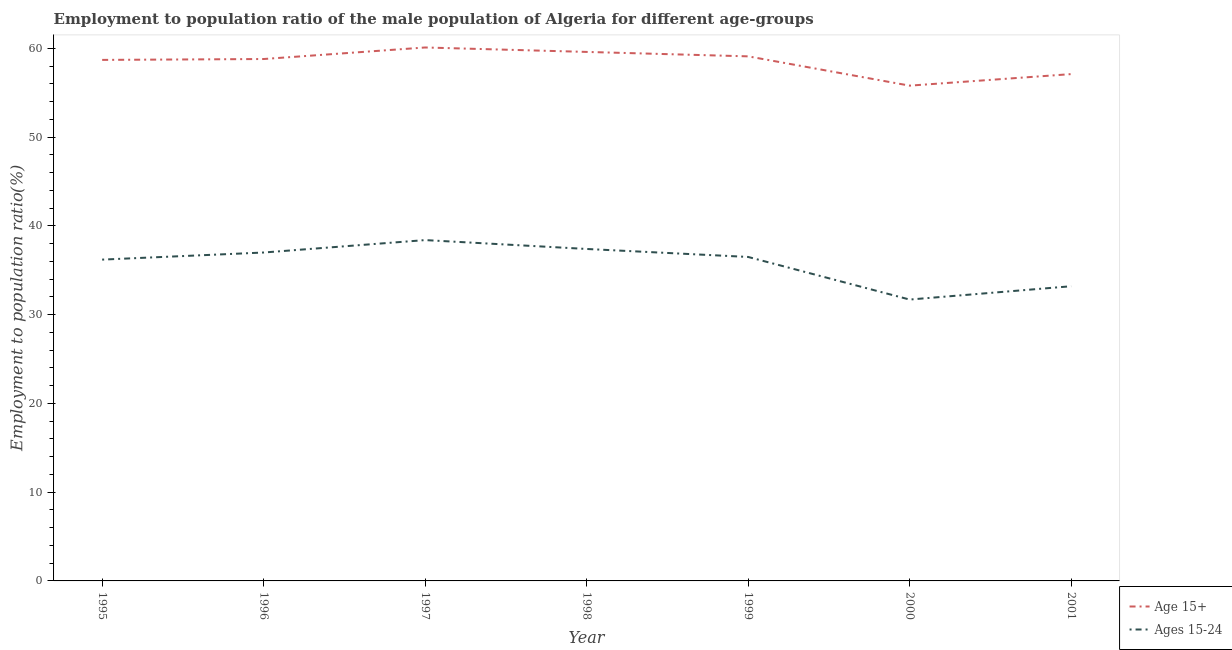How many different coloured lines are there?
Provide a succinct answer. 2. Does the line corresponding to employment to population ratio(age 15-24) intersect with the line corresponding to employment to population ratio(age 15+)?
Ensure brevity in your answer.  No. Is the number of lines equal to the number of legend labels?
Your answer should be compact. Yes. What is the employment to population ratio(age 15-24) in 1999?
Provide a short and direct response. 36.5. Across all years, what is the maximum employment to population ratio(age 15-24)?
Offer a very short reply. 38.4. Across all years, what is the minimum employment to population ratio(age 15-24)?
Offer a terse response. 31.7. In which year was the employment to population ratio(age 15+) maximum?
Ensure brevity in your answer.  1997. What is the total employment to population ratio(age 15+) in the graph?
Offer a terse response. 409.2. What is the difference between the employment to population ratio(age 15+) in 1998 and that in 2000?
Ensure brevity in your answer.  3.8. What is the difference between the employment to population ratio(age 15+) in 1996 and the employment to population ratio(age 15-24) in 1999?
Make the answer very short. 22.3. What is the average employment to population ratio(age 15+) per year?
Your answer should be compact. 58.46. In the year 1999, what is the difference between the employment to population ratio(age 15-24) and employment to population ratio(age 15+)?
Provide a succinct answer. -22.6. In how many years, is the employment to population ratio(age 15-24) greater than 44 %?
Provide a short and direct response. 0. What is the ratio of the employment to population ratio(age 15+) in 1998 to that in 2001?
Offer a very short reply. 1.04. Is the employment to population ratio(age 15+) in 1995 less than that in 1998?
Your answer should be very brief. Yes. What is the difference between the highest and the second highest employment to population ratio(age 15-24)?
Your answer should be compact. 1. What is the difference between the highest and the lowest employment to population ratio(age 15-24)?
Keep it short and to the point. 6.7. Is the sum of the employment to population ratio(age 15+) in 2000 and 2001 greater than the maximum employment to population ratio(age 15-24) across all years?
Keep it short and to the point. Yes. How many years are there in the graph?
Keep it short and to the point. 7. What is the difference between two consecutive major ticks on the Y-axis?
Make the answer very short. 10. How many legend labels are there?
Offer a very short reply. 2. What is the title of the graph?
Provide a short and direct response. Employment to population ratio of the male population of Algeria for different age-groups. Does "Travel services" appear as one of the legend labels in the graph?
Offer a very short reply. No. What is the Employment to population ratio(%) in Age 15+ in 1995?
Your answer should be compact. 58.7. What is the Employment to population ratio(%) of Ages 15-24 in 1995?
Provide a succinct answer. 36.2. What is the Employment to population ratio(%) in Age 15+ in 1996?
Provide a short and direct response. 58.8. What is the Employment to population ratio(%) of Age 15+ in 1997?
Make the answer very short. 60.1. What is the Employment to population ratio(%) in Ages 15-24 in 1997?
Keep it short and to the point. 38.4. What is the Employment to population ratio(%) in Age 15+ in 1998?
Your response must be concise. 59.6. What is the Employment to population ratio(%) in Ages 15-24 in 1998?
Offer a terse response. 37.4. What is the Employment to population ratio(%) in Age 15+ in 1999?
Offer a very short reply. 59.1. What is the Employment to population ratio(%) in Ages 15-24 in 1999?
Keep it short and to the point. 36.5. What is the Employment to population ratio(%) in Age 15+ in 2000?
Offer a terse response. 55.8. What is the Employment to population ratio(%) of Ages 15-24 in 2000?
Provide a succinct answer. 31.7. What is the Employment to population ratio(%) in Age 15+ in 2001?
Provide a succinct answer. 57.1. What is the Employment to population ratio(%) of Ages 15-24 in 2001?
Provide a succinct answer. 33.2. Across all years, what is the maximum Employment to population ratio(%) of Age 15+?
Make the answer very short. 60.1. Across all years, what is the maximum Employment to population ratio(%) of Ages 15-24?
Ensure brevity in your answer.  38.4. Across all years, what is the minimum Employment to population ratio(%) of Age 15+?
Provide a short and direct response. 55.8. Across all years, what is the minimum Employment to population ratio(%) of Ages 15-24?
Give a very brief answer. 31.7. What is the total Employment to population ratio(%) of Age 15+ in the graph?
Your answer should be very brief. 409.2. What is the total Employment to population ratio(%) of Ages 15-24 in the graph?
Offer a terse response. 250.4. What is the difference between the Employment to population ratio(%) of Age 15+ in 1995 and that in 1996?
Make the answer very short. -0.1. What is the difference between the Employment to population ratio(%) in Ages 15-24 in 1995 and that in 1997?
Your response must be concise. -2.2. What is the difference between the Employment to population ratio(%) of Ages 15-24 in 1995 and that in 1998?
Provide a succinct answer. -1.2. What is the difference between the Employment to population ratio(%) in Ages 15-24 in 1995 and that in 2000?
Give a very brief answer. 4.5. What is the difference between the Employment to population ratio(%) in Age 15+ in 1996 and that in 1997?
Give a very brief answer. -1.3. What is the difference between the Employment to population ratio(%) in Ages 15-24 in 1996 and that in 1998?
Your answer should be compact. -0.4. What is the difference between the Employment to population ratio(%) of Age 15+ in 1996 and that in 1999?
Provide a short and direct response. -0.3. What is the difference between the Employment to population ratio(%) of Ages 15-24 in 1996 and that in 1999?
Make the answer very short. 0.5. What is the difference between the Employment to population ratio(%) of Ages 15-24 in 1996 and that in 2001?
Your answer should be compact. 3.8. What is the difference between the Employment to population ratio(%) in Ages 15-24 in 1997 and that in 1999?
Your answer should be compact. 1.9. What is the difference between the Employment to population ratio(%) of Age 15+ in 1997 and that in 2000?
Your response must be concise. 4.3. What is the difference between the Employment to population ratio(%) in Age 15+ in 1997 and that in 2001?
Keep it short and to the point. 3. What is the difference between the Employment to population ratio(%) in Ages 15-24 in 1997 and that in 2001?
Provide a succinct answer. 5.2. What is the difference between the Employment to population ratio(%) of Ages 15-24 in 1998 and that in 1999?
Your answer should be very brief. 0.9. What is the difference between the Employment to population ratio(%) in Age 15+ in 1998 and that in 2000?
Your response must be concise. 3.8. What is the difference between the Employment to population ratio(%) of Age 15+ in 1998 and that in 2001?
Provide a short and direct response. 2.5. What is the difference between the Employment to population ratio(%) in Age 15+ in 1999 and that in 2000?
Provide a short and direct response. 3.3. What is the difference between the Employment to population ratio(%) in Age 15+ in 2000 and that in 2001?
Provide a short and direct response. -1.3. What is the difference between the Employment to population ratio(%) in Ages 15-24 in 2000 and that in 2001?
Make the answer very short. -1.5. What is the difference between the Employment to population ratio(%) in Age 15+ in 1995 and the Employment to population ratio(%) in Ages 15-24 in 1996?
Offer a very short reply. 21.7. What is the difference between the Employment to population ratio(%) of Age 15+ in 1995 and the Employment to population ratio(%) of Ages 15-24 in 1997?
Give a very brief answer. 20.3. What is the difference between the Employment to population ratio(%) of Age 15+ in 1995 and the Employment to population ratio(%) of Ages 15-24 in 1998?
Keep it short and to the point. 21.3. What is the difference between the Employment to population ratio(%) of Age 15+ in 1995 and the Employment to population ratio(%) of Ages 15-24 in 2001?
Your response must be concise. 25.5. What is the difference between the Employment to population ratio(%) of Age 15+ in 1996 and the Employment to population ratio(%) of Ages 15-24 in 1997?
Make the answer very short. 20.4. What is the difference between the Employment to population ratio(%) of Age 15+ in 1996 and the Employment to population ratio(%) of Ages 15-24 in 1998?
Your response must be concise. 21.4. What is the difference between the Employment to population ratio(%) of Age 15+ in 1996 and the Employment to population ratio(%) of Ages 15-24 in 1999?
Give a very brief answer. 22.3. What is the difference between the Employment to population ratio(%) of Age 15+ in 1996 and the Employment to population ratio(%) of Ages 15-24 in 2000?
Your answer should be very brief. 27.1. What is the difference between the Employment to population ratio(%) of Age 15+ in 1996 and the Employment to population ratio(%) of Ages 15-24 in 2001?
Provide a succinct answer. 25.6. What is the difference between the Employment to population ratio(%) of Age 15+ in 1997 and the Employment to population ratio(%) of Ages 15-24 in 1998?
Provide a succinct answer. 22.7. What is the difference between the Employment to population ratio(%) of Age 15+ in 1997 and the Employment to population ratio(%) of Ages 15-24 in 1999?
Your response must be concise. 23.6. What is the difference between the Employment to population ratio(%) of Age 15+ in 1997 and the Employment to population ratio(%) of Ages 15-24 in 2000?
Provide a short and direct response. 28.4. What is the difference between the Employment to population ratio(%) of Age 15+ in 1997 and the Employment to population ratio(%) of Ages 15-24 in 2001?
Your answer should be very brief. 26.9. What is the difference between the Employment to population ratio(%) of Age 15+ in 1998 and the Employment to population ratio(%) of Ages 15-24 in 1999?
Give a very brief answer. 23.1. What is the difference between the Employment to population ratio(%) in Age 15+ in 1998 and the Employment to population ratio(%) in Ages 15-24 in 2000?
Your answer should be compact. 27.9. What is the difference between the Employment to population ratio(%) of Age 15+ in 1998 and the Employment to population ratio(%) of Ages 15-24 in 2001?
Your answer should be very brief. 26.4. What is the difference between the Employment to population ratio(%) in Age 15+ in 1999 and the Employment to population ratio(%) in Ages 15-24 in 2000?
Ensure brevity in your answer.  27.4. What is the difference between the Employment to population ratio(%) of Age 15+ in 1999 and the Employment to population ratio(%) of Ages 15-24 in 2001?
Keep it short and to the point. 25.9. What is the difference between the Employment to population ratio(%) in Age 15+ in 2000 and the Employment to population ratio(%) in Ages 15-24 in 2001?
Provide a short and direct response. 22.6. What is the average Employment to population ratio(%) of Age 15+ per year?
Provide a succinct answer. 58.46. What is the average Employment to population ratio(%) of Ages 15-24 per year?
Provide a succinct answer. 35.77. In the year 1996, what is the difference between the Employment to population ratio(%) in Age 15+ and Employment to population ratio(%) in Ages 15-24?
Your response must be concise. 21.8. In the year 1997, what is the difference between the Employment to population ratio(%) in Age 15+ and Employment to population ratio(%) in Ages 15-24?
Provide a short and direct response. 21.7. In the year 1999, what is the difference between the Employment to population ratio(%) in Age 15+ and Employment to population ratio(%) in Ages 15-24?
Provide a succinct answer. 22.6. In the year 2000, what is the difference between the Employment to population ratio(%) in Age 15+ and Employment to population ratio(%) in Ages 15-24?
Ensure brevity in your answer.  24.1. In the year 2001, what is the difference between the Employment to population ratio(%) in Age 15+ and Employment to population ratio(%) in Ages 15-24?
Offer a terse response. 23.9. What is the ratio of the Employment to population ratio(%) of Ages 15-24 in 1995 to that in 1996?
Your response must be concise. 0.98. What is the ratio of the Employment to population ratio(%) in Age 15+ in 1995 to that in 1997?
Keep it short and to the point. 0.98. What is the ratio of the Employment to population ratio(%) in Ages 15-24 in 1995 to that in 1997?
Keep it short and to the point. 0.94. What is the ratio of the Employment to population ratio(%) of Age 15+ in 1995 to that in 1998?
Make the answer very short. 0.98. What is the ratio of the Employment to population ratio(%) of Ages 15-24 in 1995 to that in 1998?
Your response must be concise. 0.97. What is the ratio of the Employment to population ratio(%) in Age 15+ in 1995 to that in 2000?
Give a very brief answer. 1.05. What is the ratio of the Employment to population ratio(%) in Ages 15-24 in 1995 to that in 2000?
Offer a very short reply. 1.14. What is the ratio of the Employment to population ratio(%) in Age 15+ in 1995 to that in 2001?
Provide a succinct answer. 1.03. What is the ratio of the Employment to population ratio(%) in Ages 15-24 in 1995 to that in 2001?
Provide a short and direct response. 1.09. What is the ratio of the Employment to population ratio(%) in Age 15+ in 1996 to that in 1997?
Your answer should be very brief. 0.98. What is the ratio of the Employment to population ratio(%) in Ages 15-24 in 1996 to that in 1997?
Keep it short and to the point. 0.96. What is the ratio of the Employment to population ratio(%) in Age 15+ in 1996 to that in 1998?
Make the answer very short. 0.99. What is the ratio of the Employment to population ratio(%) in Ages 15-24 in 1996 to that in 1998?
Offer a terse response. 0.99. What is the ratio of the Employment to population ratio(%) of Ages 15-24 in 1996 to that in 1999?
Keep it short and to the point. 1.01. What is the ratio of the Employment to population ratio(%) in Age 15+ in 1996 to that in 2000?
Offer a very short reply. 1.05. What is the ratio of the Employment to population ratio(%) of Ages 15-24 in 1996 to that in 2000?
Provide a short and direct response. 1.17. What is the ratio of the Employment to population ratio(%) in Age 15+ in 1996 to that in 2001?
Make the answer very short. 1.03. What is the ratio of the Employment to population ratio(%) in Ages 15-24 in 1996 to that in 2001?
Your response must be concise. 1.11. What is the ratio of the Employment to population ratio(%) of Age 15+ in 1997 to that in 1998?
Your response must be concise. 1.01. What is the ratio of the Employment to population ratio(%) in Ages 15-24 in 1997 to that in 1998?
Provide a succinct answer. 1.03. What is the ratio of the Employment to population ratio(%) in Age 15+ in 1997 to that in 1999?
Provide a succinct answer. 1.02. What is the ratio of the Employment to population ratio(%) of Ages 15-24 in 1997 to that in 1999?
Give a very brief answer. 1.05. What is the ratio of the Employment to population ratio(%) of Age 15+ in 1997 to that in 2000?
Offer a terse response. 1.08. What is the ratio of the Employment to population ratio(%) of Ages 15-24 in 1997 to that in 2000?
Provide a short and direct response. 1.21. What is the ratio of the Employment to population ratio(%) of Age 15+ in 1997 to that in 2001?
Your answer should be compact. 1.05. What is the ratio of the Employment to population ratio(%) in Ages 15-24 in 1997 to that in 2001?
Your answer should be compact. 1.16. What is the ratio of the Employment to population ratio(%) of Age 15+ in 1998 to that in 1999?
Your answer should be very brief. 1.01. What is the ratio of the Employment to population ratio(%) in Ages 15-24 in 1998 to that in 1999?
Keep it short and to the point. 1.02. What is the ratio of the Employment to population ratio(%) in Age 15+ in 1998 to that in 2000?
Provide a succinct answer. 1.07. What is the ratio of the Employment to population ratio(%) in Ages 15-24 in 1998 to that in 2000?
Offer a terse response. 1.18. What is the ratio of the Employment to population ratio(%) in Age 15+ in 1998 to that in 2001?
Your response must be concise. 1.04. What is the ratio of the Employment to population ratio(%) in Ages 15-24 in 1998 to that in 2001?
Your answer should be very brief. 1.13. What is the ratio of the Employment to population ratio(%) of Age 15+ in 1999 to that in 2000?
Offer a terse response. 1.06. What is the ratio of the Employment to population ratio(%) of Ages 15-24 in 1999 to that in 2000?
Your answer should be compact. 1.15. What is the ratio of the Employment to population ratio(%) in Age 15+ in 1999 to that in 2001?
Make the answer very short. 1.03. What is the ratio of the Employment to population ratio(%) in Ages 15-24 in 1999 to that in 2001?
Keep it short and to the point. 1.1. What is the ratio of the Employment to population ratio(%) in Age 15+ in 2000 to that in 2001?
Your answer should be very brief. 0.98. What is the ratio of the Employment to population ratio(%) of Ages 15-24 in 2000 to that in 2001?
Your answer should be compact. 0.95. What is the difference between the highest and the second highest Employment to population ratio(%) of Ages 15-24?
Keep it short and to the point. 1. What is the difference between the highest and the lowest Employment to population ratio(%) of Age 15+?
Provide a short and direct response. 4.3. 